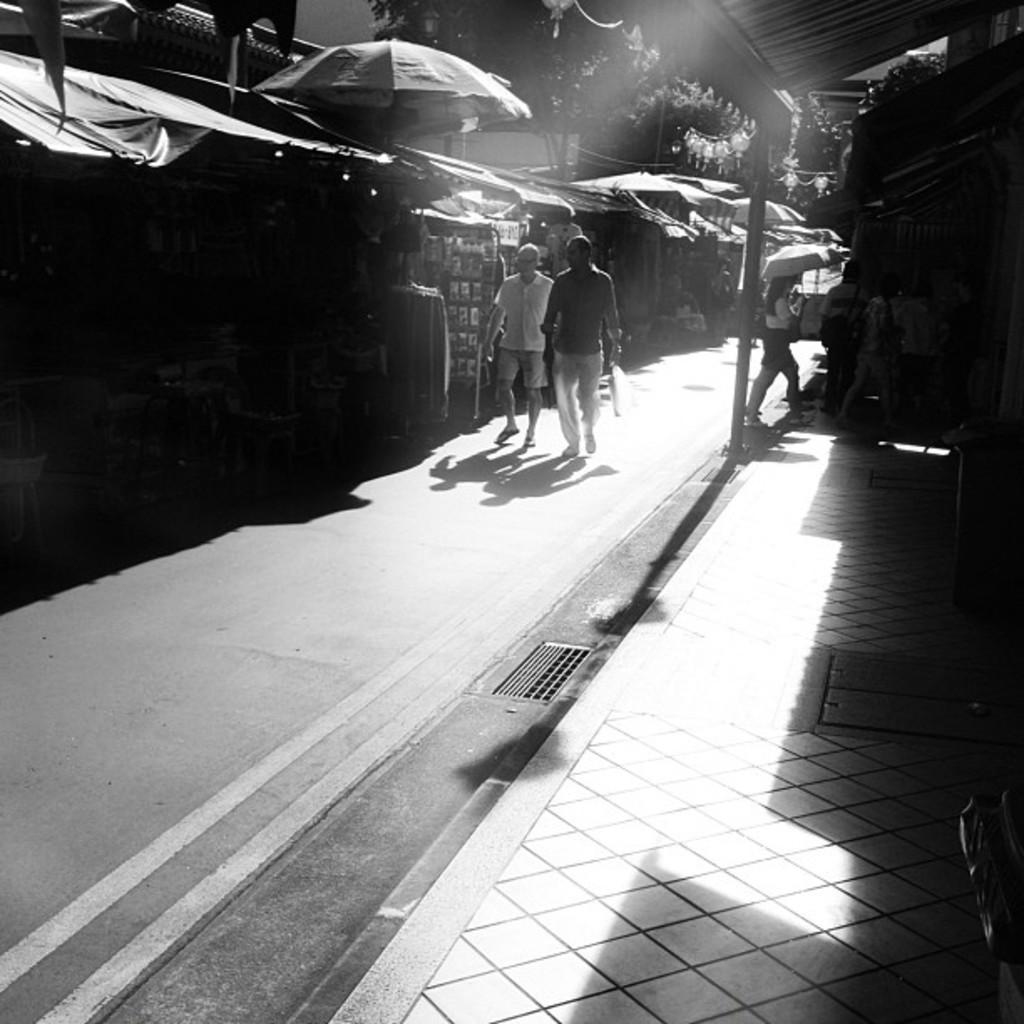How many people are in the image? There are two men in the image. What are the men doing in the image? The men are walking on the road. What can be seen in the background of the image? There is a shop, an umbrella, vehicles, trees, and a building visible in the image. What book is the man reading while walking in the image? There is no book present in the image, and the men are walking, not reading. 